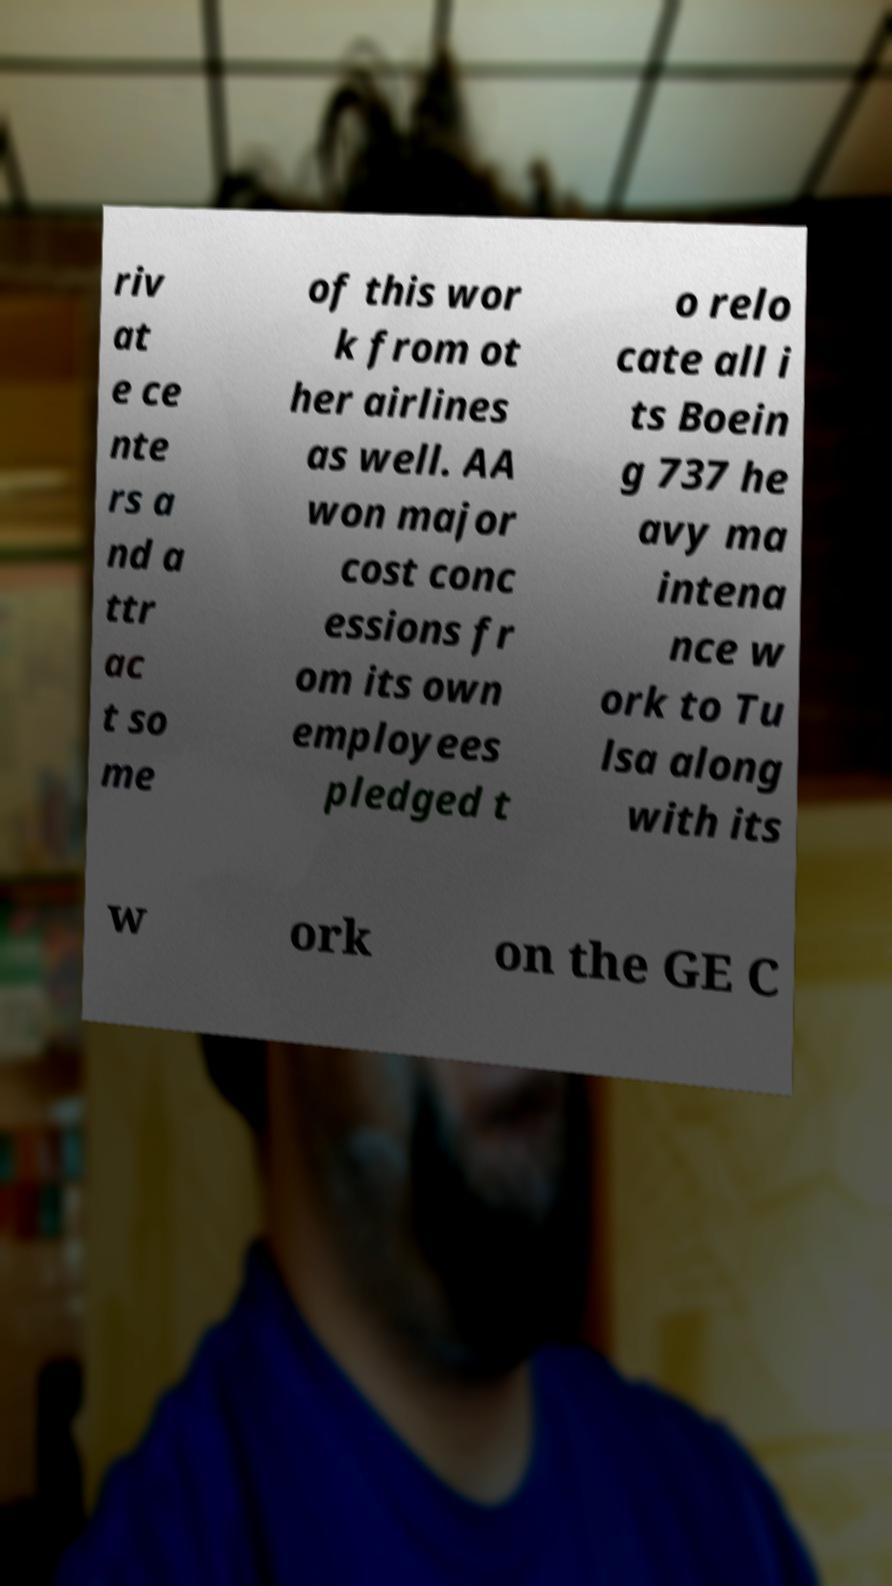Can you read and provide the text displayed in the image?This photo seems to have some interesting text. Can you extract and type it out for me? riv at e ce nte rs a nd a ttr ac t so me of this wor k from ot her airlines as well. AA won major cost conc essions fr om its own employees pledged t o relo cate all i ts Boein g 737 he avy ma intena nce w ork to Tu lsa along with its w ork on the GE C 